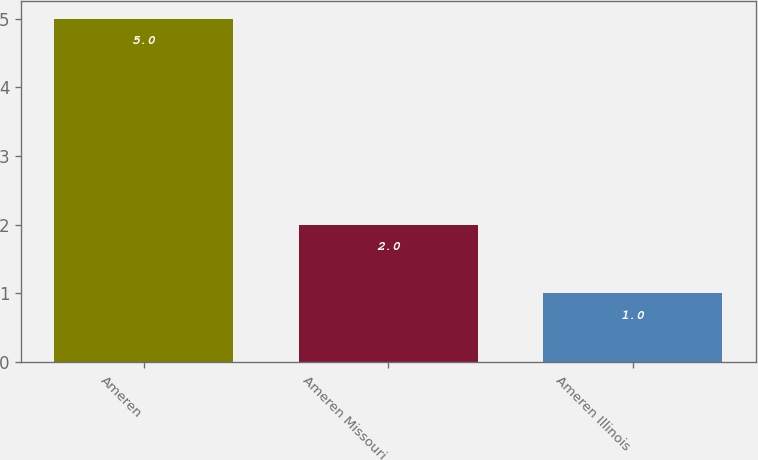Convert chart. <chart><loc_0><loc_0><loc_500><loc_500><bar_chart><fcel>Ameren<fcel>Ameren Missouri<fcel>Ameren Illinois<nl><fcel>5<fcel>2<fcel>1<nl></chart> 